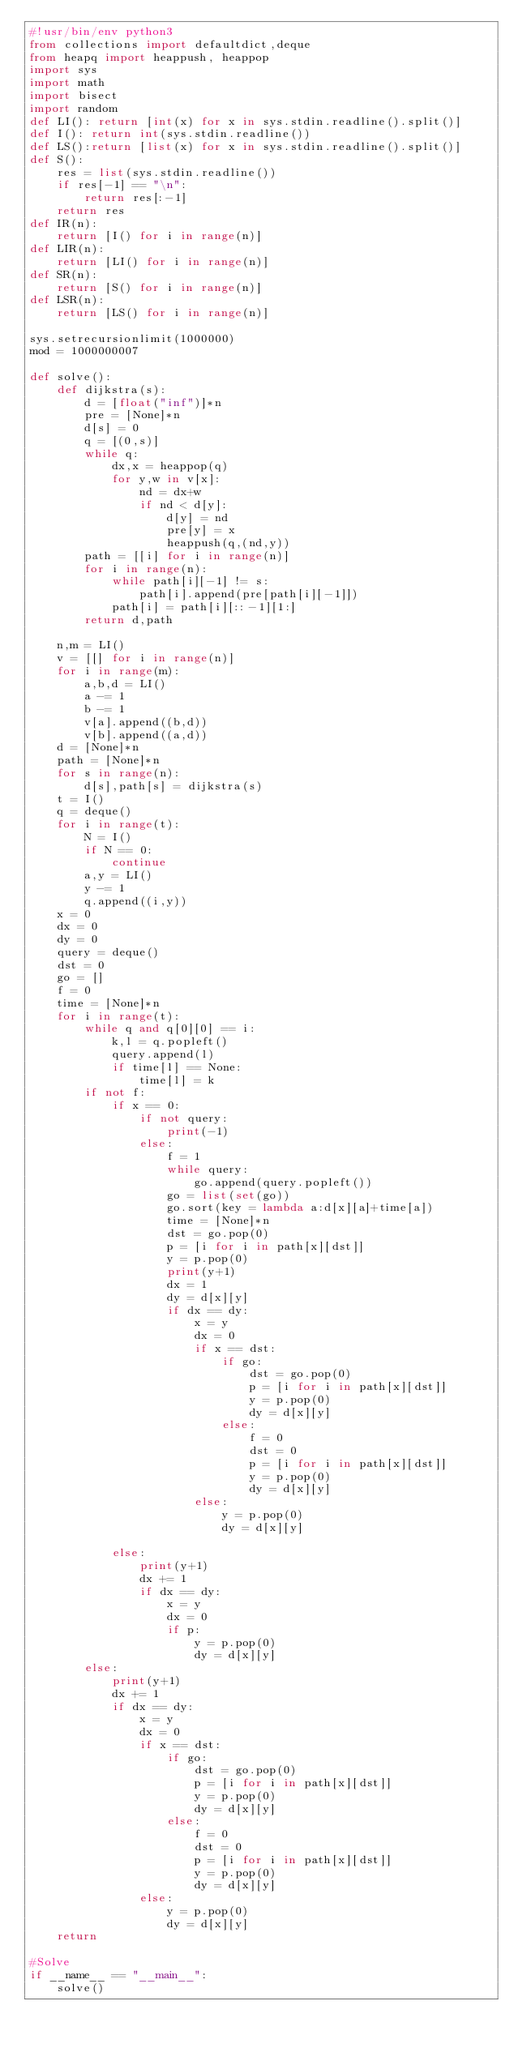<code> <loc_0><loc_0><loc_500><loc_500><_Python_>#!usr/bin/env python3
from collections import defaultdict,deque
from heapq import heappush, heappop
import sys
import math
import bisect
import random
def LI(): return [int(x) for x in sys.stdin.readline().split()]
def I(): return int(sys.stdin.readline())
def LS():return [list(x) for x in sys.stdin.readline().split()]
def S():
    res = list(sys.stdin.readline())
    if res[-1] == "\n":
        return res[:-1]
    return res
def IR(n):
    return [I() for i in range(n)]
def LIR(n):
    return [LI() for i in range(n)]
def SR(n):
    return [S() for i in range(n)]
def LSR(n):
    return [LS() for i in range(n)]

sys.setrecursionlimit(1000000)
mod = 1000000007

def solve():
    def dijkstra(s):
        d = [float("inf")]*n
        pre = [None]*n
        d[s] = 0
        q = [(0,s)]
        while q:
            dx,x = heappop(q)
            for y,w in v[x]:
                nd = dx+w
                if nd < d[y]:
                    d[y] = nd
                    pre[y] = x
                    heappush(q,(nd,y))
        path = [[i] for i in range(n)]
        for i in range(n):
            while path[i][-1] != s:
                path[i].append(pre[path[i][-1]])
            path[i] = path[i][::-1][1:]
        return d,path

    n,m = LI()
    v = [[] for i in range(n)]
    for i in range(m):
        a,b,d = LI()
        a -= 1
        b -= 1
        v[a].append((b,d))
        v[b].append((a,d))
    d = [None]*n
    path = [None]*n
    for s in range(n):
        d[s],path[s] = dijkstra(s)
    t = I()
    q = deque()
    for i in range(t):
        N = I()
        if N == 0:
            continue
        a,y = LI()
        y -= 1
        q.append((i,y))
    x = 0
    dx = 0
    dy = 0
    query = deque()
    dst = 0
    go = []
    f = 0
    time = [None]*n
    for i in range(t):
        while q and q[0][0] == i:
            k,l = q.popleft()
            query.append(l)
            if time[l] == None:
                time[l] = k
        if not f:
            if x == 0:
                if not query:
                    print(-1)
                else:
                    f = 1
                    while query:
                        go.append(query.popleft())
                    go = list(set(go))
                    go.sort(key = lambda a:d[x][a]+time[a])
                    time = [None]*n
                    dst = go.pop(0)
                    p = [i for i in path[x][dst]]
                    y = p.pop(0)
                    print(y+1)
                    dx = 1
                    dy = d[x][y]
                    if dx == dy:
                        x = y
                        dx = 0
                        if x == dst:
                            if go:
                                dst = go.pop(0)
                                p = [i for i in path[x][dst]]
                                y = p.pop(0)
                                dy = d[x][y]
                            else:
                                f = 0
                                dst = 0
                                p = [i for i in path[x][dst]]
                                y = p.pop(0)
                                dy = d[x][y]
                        else:
                            y = p.pop(0)
                            dy = d[x][y]

            else:
                print(y+1)
                dx += 1
                if dx == dy:
                    x = y
                    dx = 0
                    if p:
                        y = p.pop(0)
                        dy = d[x][y]
        else:
            print(y+1)
            dx += 1
            if dx == dy:
                x = y
                dx = 0
                if x == dst:
                    if go:
                        dst = go.pop(0)
                        p = [i for i in path[x][dst]]
                        y = p.pop(0)
                        dy = d[x][y]
                    else:
                        f = 0
                        dst = 0
                        p = [i for i in path[x][dst]]
                        y = p.pop(0)
                        dy = d[x][y]
                else:
                    y = p.pop(0)
                    dy = d[x][y]
    return

#Solve
if __name__ == "__main__":
    solve()
</code> 